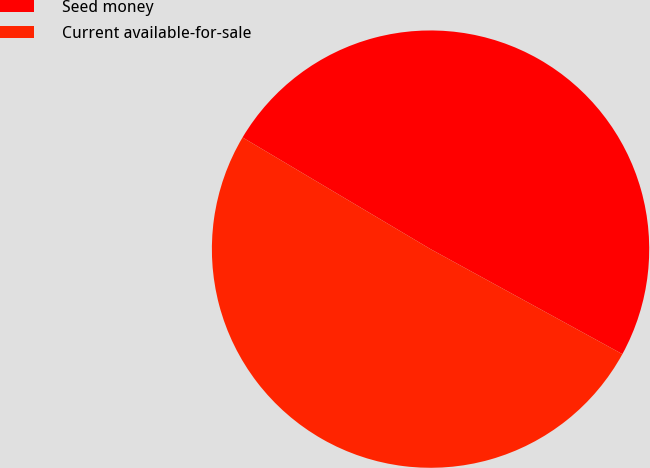<chart> <loc_0><loc_0><loc_500><loc_500><pie_chart><fcel>Seed money<fcel>Current available-for-sale<nl><fcel>49.44%<fcel>50.56%<nl></chart> 